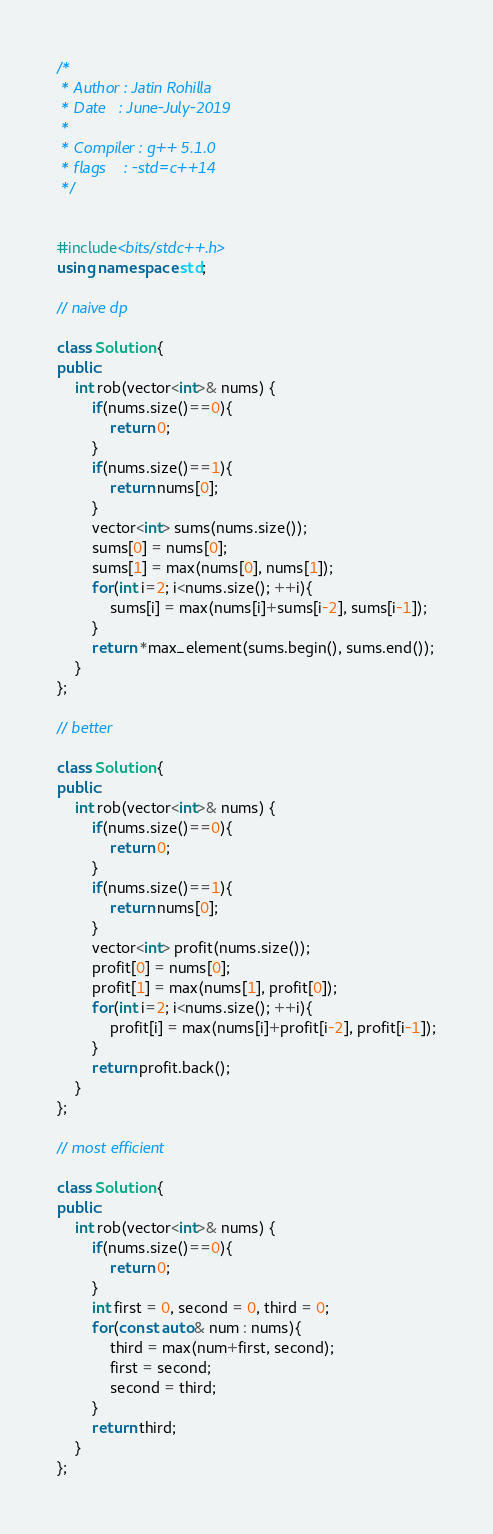Convert code to text. <code><loc_0><loc_0><loc_500><loc_500><_C++_>/*
 * Author : Jatin Rohilla
 * Date   : June-July-2019
 *
 * Compiler : g++ 5.1.0
 * flags    : -std=c++14
 */


#include<bits/stdc++.h>
using namespace std;

// naive dp

class Solution {
public:
    int rob(vector<int>& nums) {
        if(nums.size()==0){
            return 0;
        }
        if(nums.size()==1){
            return nums[0];
        }
        vector<int> sums(nums.size());
        sums[0] = nums[0];
        sums[1] = max(nums[0], nums[1]);
        for(int i=2; i<nums.size(); ++i){
            sums[i] = max(nums[i]+sums[i-2], sums[i-1]);
        }
        return *max_element(sums.begin(), sums.end());
    }
};

// better

class Solution {
public:
    int rob(vector<int>& nums) {
        if(nums.size()==0){
            return 0;
        }
        if(nums.size()==1){
            return nums[0];
        }
        vector<int> profit(nums.size());
        profit[0] = nums[0];
        profit[1] = max(nums[1], profit[0]);
        for(int i=2; i<nums.size(); ++i){
            profit[i] = max(nums[i]+profit[i-2], profit[i-1]);
        }
        return profit.back();
    }
};

// most efficient

class Solution {
public:
    int rob(vector<int>& nums) {
        if(nums.size()==0){
            return 0;
        }
        int first = 0, second = 0, third = 0;
        for(const auto& num : nums){
            third = max(num+first, second);
            first = second;
            second = third;
        }
        return third;
    }
};

</code> 